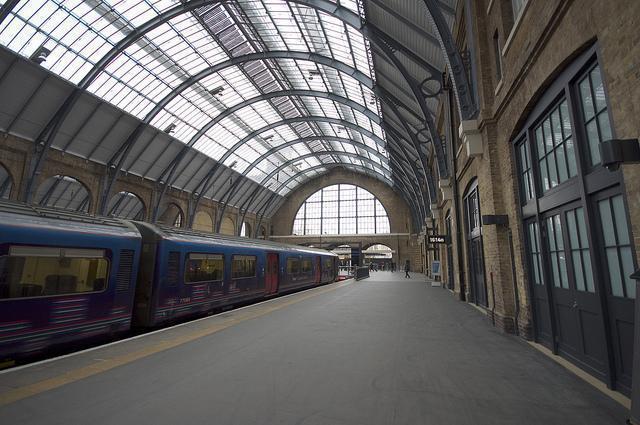What kind of payment is needed for an opportunity to ride this machine?
Select the accurate response from the four choices given to answer the question.
Options: Donation, fare, salary payment, volunteer payment. Fare. 